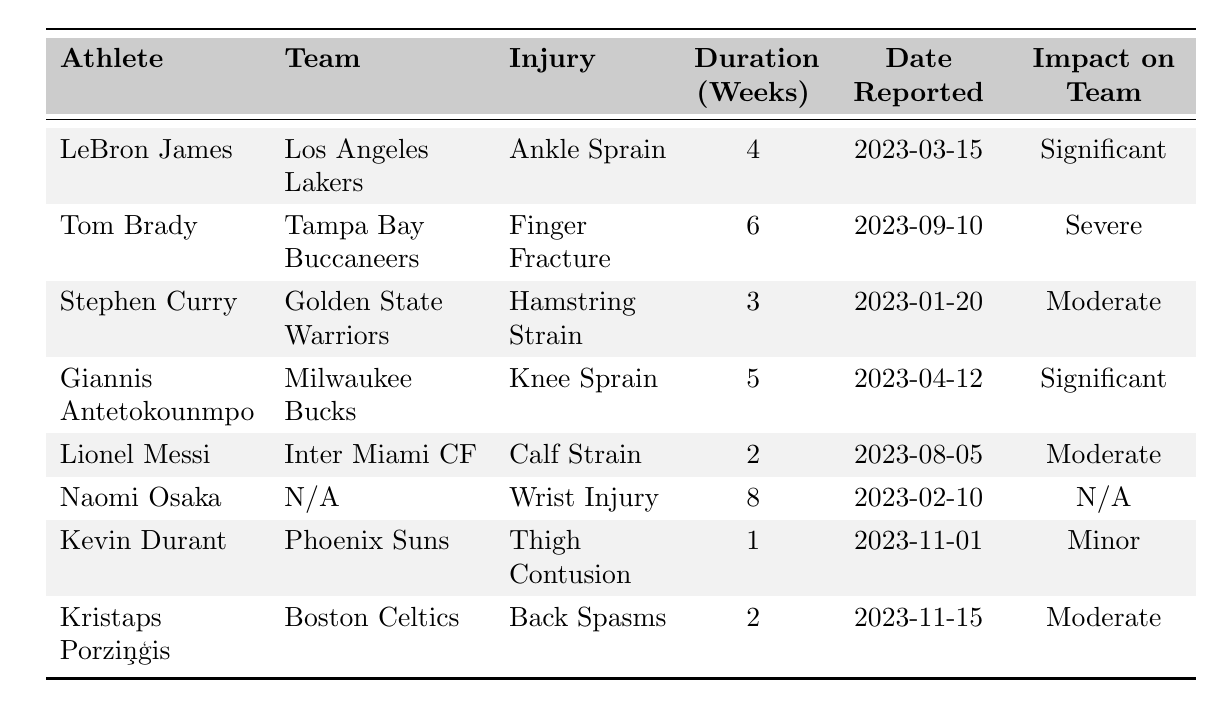What is the total duration of injuries for all athletes listed? To find the total duration, sum the duration of injuries for each athlete: 4 (LeBron) + 6 (Tom) + 3 (Stephen) + 5 (Giannis) + 2 (Lionel) + 8 (Naomi) + 1 (Kevin) + 2 (Kristaps) = 31 weeks.
Answer: 31 weeks Which athlete reported their injury first? Looking at the "Date Reported" column, the earliest date is 2023-01-20, which belongs to Stephen Curry.
Answer: Stephen Curry How many players have a significant impact on their teams? The athletes with a "Significant" impact are LeBron James and Giannis Antetokounmpo, making a total of 2 players.
Answer: 2 players What is the average duration of injuries for the athletes? To calculate the average, sum the durations (31 weeks) and divide by the number of athletes (8): 31 / 8 = 3.875 weeks.
Answer: 3.875 weeks Is there an athlete on the list with an injury duration of less than 2 weeks? Checking the "Duration (Weeks)" column, the minimum duration is 1 week (Kevin Durant), confirming there is one.
Answer: Yes What is the maximum injury duration among the athletes? Scan the "Duration (Weeks)" column to identify the maximum, which is 8 weeks (Naomi Osaka).
Answer: 8 weeks Which athlete has the most severe impact on their team? There’s one athlete indicating a "Severe" impact, which is Tom Brady.
Answer: Tom Brady How many athletes were reported to have a moderate impact on their teams? The athletes with "Moderate" impact are Stephen Curry, Lionel Messi, and Kristaps Porziņģis, totaling 3 athletes.
Answer: 3 athletes What is the total number of weeks lost due to injuries for athletes with significant impacts? The durations for significant impacts are 4 weeks (LeBron) and 5 weeks (Giannis), totaling 9 weeks: 4 + 5 = 9 weeks.
Answer: 9 weeks Which athlete's team is facing the most severe impact due to injury? Since Tom Brady's impact is categorized as "Severe," his injury causes the greatest concern for the team.
Answer: Tom Brady 